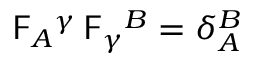<formula> <loc_0><loc_0><loc_500><loc_500>F _ { A ^ { \gamma } \, F _ { \gamma ^ { B } = \delta _ { A } ^ { B }</formula> 